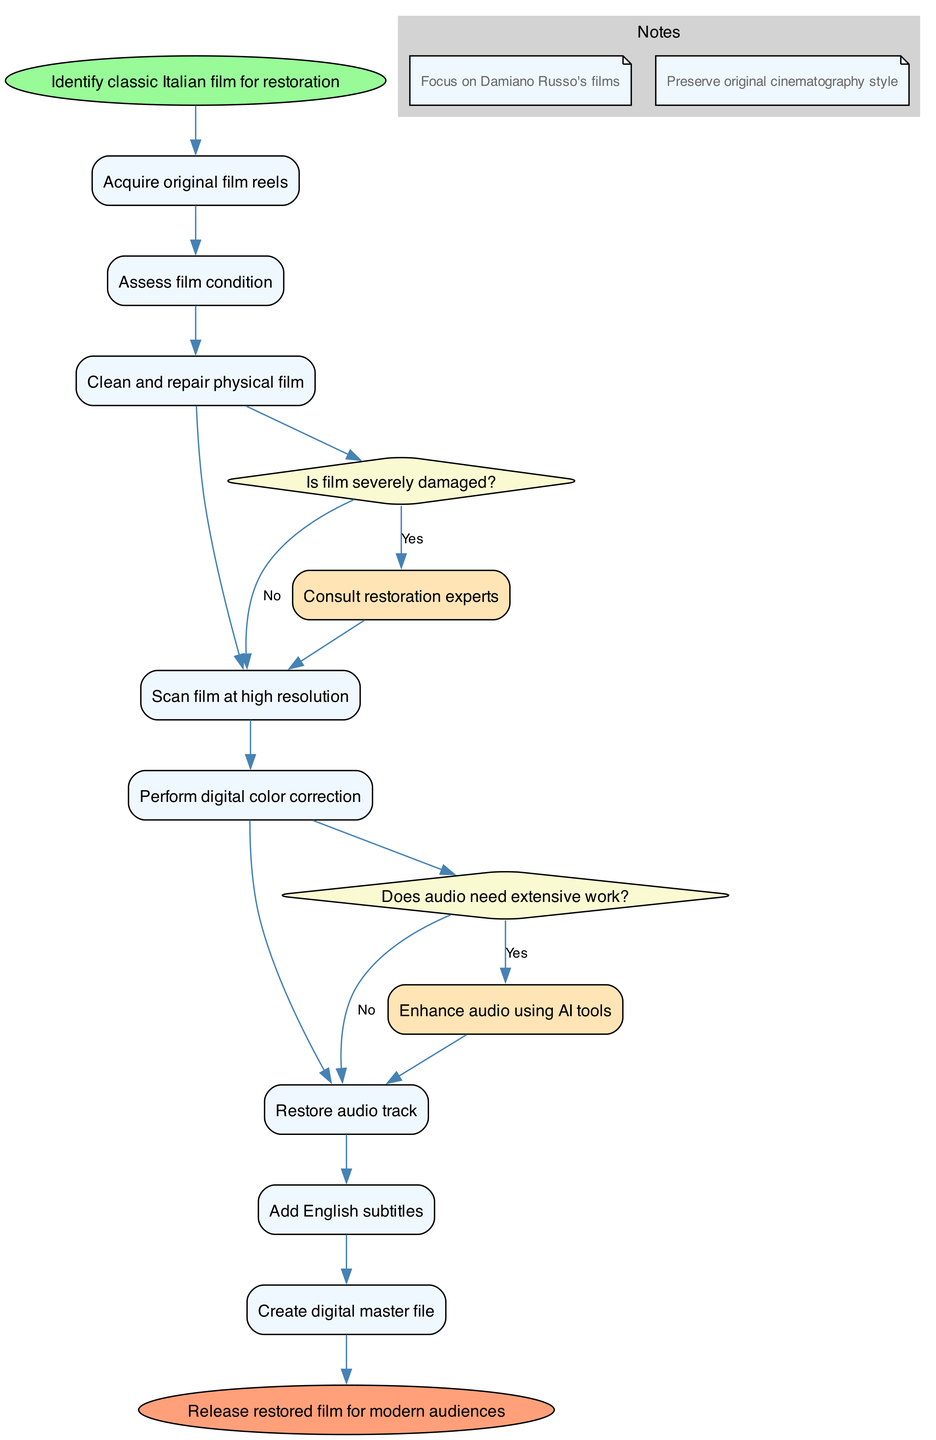What is the starting node of the diagram? The starting node in the diagram is labeled "Identify classic Italian film for restoration," which is the first action before any activities take place.
Answer: Identify classic Italian film for restoration How many activities are present in the diagram? By counting the activities listed, there are a total of eight activities included in the process of restoring and digitizing classic Italian films.
Answer: 8 What decision follows the "Assess film condition" activity? The decision that follows "Assess film condition" is questioning if the film is severely damaged, indicating a branching point in the workflow.
Answer: Is film severely damaged? If the film is not severely damaged, what is the next step? The next step after determining that the film is not severely damaged is to proceed with standard restoration, as indicated in the diagram.
Answer: Proceed with standard restoration How many decisions are included in the diagram? The diagram includes two decision nodes, each representing a critical point where different outcomes can lead to different next steps in the restoration process.
Answer: 2 What is the final action taken before releasing the film? The final action before the film is released is to create the digital master file, which is essential for preserving the film in a modern format.
Answer: Create digital master file What happens if the audio needs extensive work? If the audio needs extensive work, the process will enhance the audio using AI tools, which is explicitly defined in the diagram's decision-making flow.
Answer: Enhance audio using AI tools What is the purpose of the notes section in the diagram? The notes section emphasizes the focus on Damiano Russo's films and highlights the importance of preserving the original cinematography style during the restoration process.
Answer: Preserve original cinematography style What is the end node of the diagram? The end node of the diagram signifies the conclusion of the restoration process, which is labeled "Release restored film for modern audiences."
Answer: Release restored film for modern audiences 